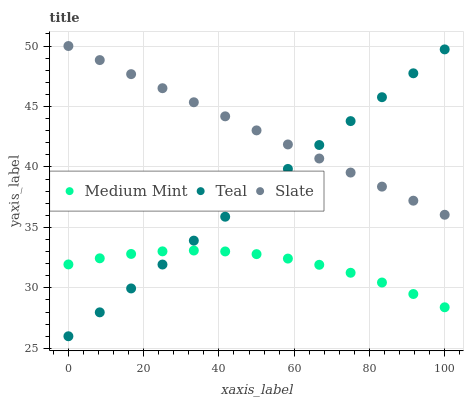Does Medium Mint have the minimum area under the curve?
Answer yes or no. Yes. Does Slate have the maximum area under the curve?
Answer yes or no. Yes. Does Teal have the minimum area under the curve?
Answer yes or no. No. Does Teal have the maximum area under the curve?
Answer yes or no. No. Is Teal the smoothest?
Answer yes or no. Yes. Is Medium Mint the roughest?
Answer yes or no. Yes. Is Slate the smoothest?
Answer yes or no. No. Is Slate the roughest?
Answer yes or no. No. Does Teal have the lowest value?
Answer yes or no. Yes. Does Slate have the lowest value?
Answer yes or no. No. Does Slate have the highest value?
Answer yes or no. Yes. Does Teal have the highest value?
Answer yes or no. No. Is Medium Mint less than Slate?
Answer yes or no. Yes. Is Slate greater than Medium Mint?
Answer yes or no. Yes. Does Medium Mint intersect Teal?
Answer yes or no. Yes. Is Medium Mint less than Teal?
Answer yes or no. No. Is Medium Mint greater than Teal?
Answer yes or no. No. Does Medium Mint intersect Slate?
Answer yes or no. No. 